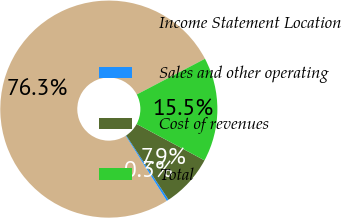Convert chart. <chart><loc_0><loc_0><loc_500><loc_500><pie_chart><fcel>Income Statement Location<fcel>Sales and other operating<fcel>Cost of revenues<fcel>Total<nl><fcel>76.29%<fcel>0.3%<fcel>7.9%<fcel>15.5%<nl></chart> 